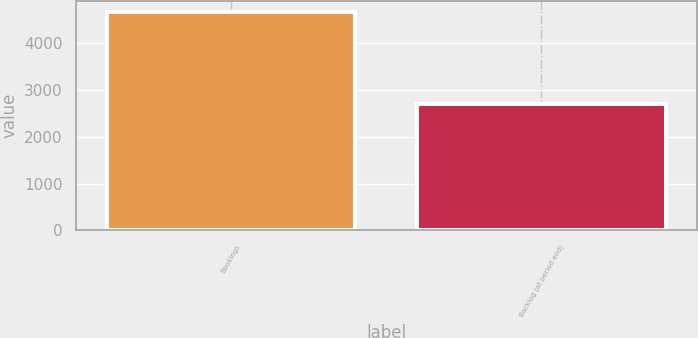Convert chart to OTSL. <chart><loc_0><loc_0><loc_500><loc_500><bar_chart><fcel>Bookings<fcel>Backlog (at period end)<nl><fcel>4661.9<fcel>2690.1<nl></chart> 